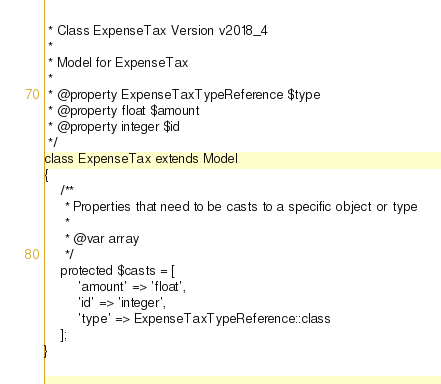<code> <loc_0><loc_0><loc_500><loc_500><_PHP_> * Class ExpenseTax Version v2018_4
 *
 * Model for ExpenseTax
 *
 * @property ExpenseTaxTypeReference $type
 * @property float $amount
 * @property integer $id
 */
class ExpenseTax extends Model
{
    /**
     * Properties that need to be casts to a specific object or type
     *
     * @var array
     */
    protected $casts = [
        'amount' => 'float',
        'id' => 'integer',
        'type' => ExpenseTaxTypeReference::class
    ];
}
</code> 